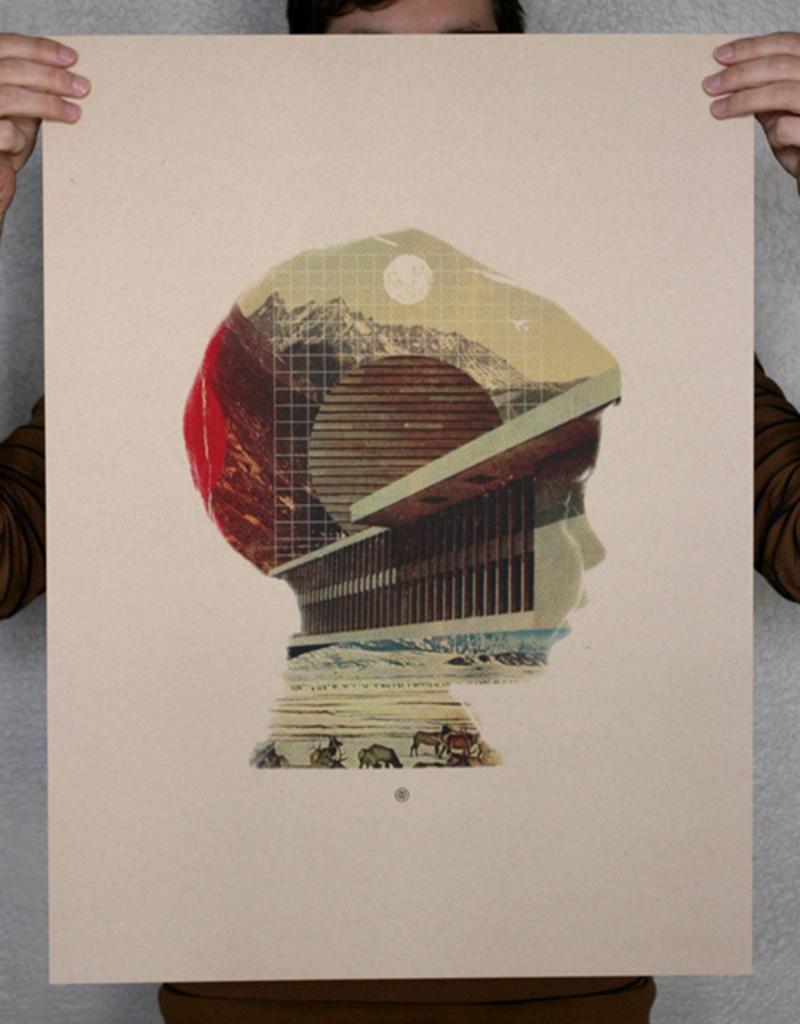How would you summarize this image in a sentence or two? In the image there is a person holding a cardboard with a graphic image of a boy in it, behind him there is a wall. 